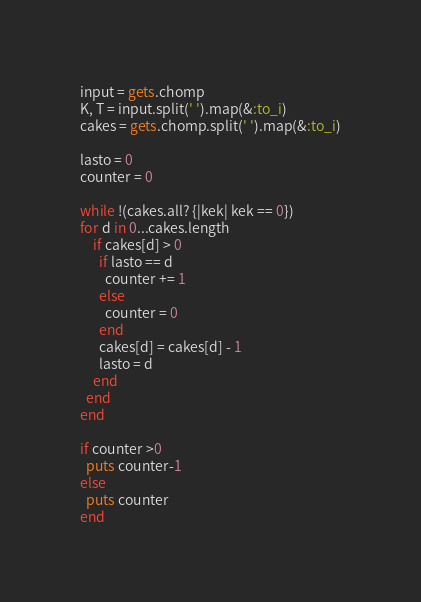<code> <loc_0><loc_0><loc_500><loc_500><_Ruby_>input = gets.chomp
K, T = input.split(' ').map(&:to_i)
cakes = gets.chomp.split(' ').map(&:to_i)

lasto = 0
counter = 0

while !(cakes.all? {|kek| kek == 0})
for d in 0...cakes.length
    if cakes[d] > 0
      if lasto == d
        counter += 1
      else
        counter = 0
      end
      cakes[d] = cakes[d] - 1
      lasto = d
    end
  end
end

if counter >0
  puts counter-1
else
  puts counter
end</code> 